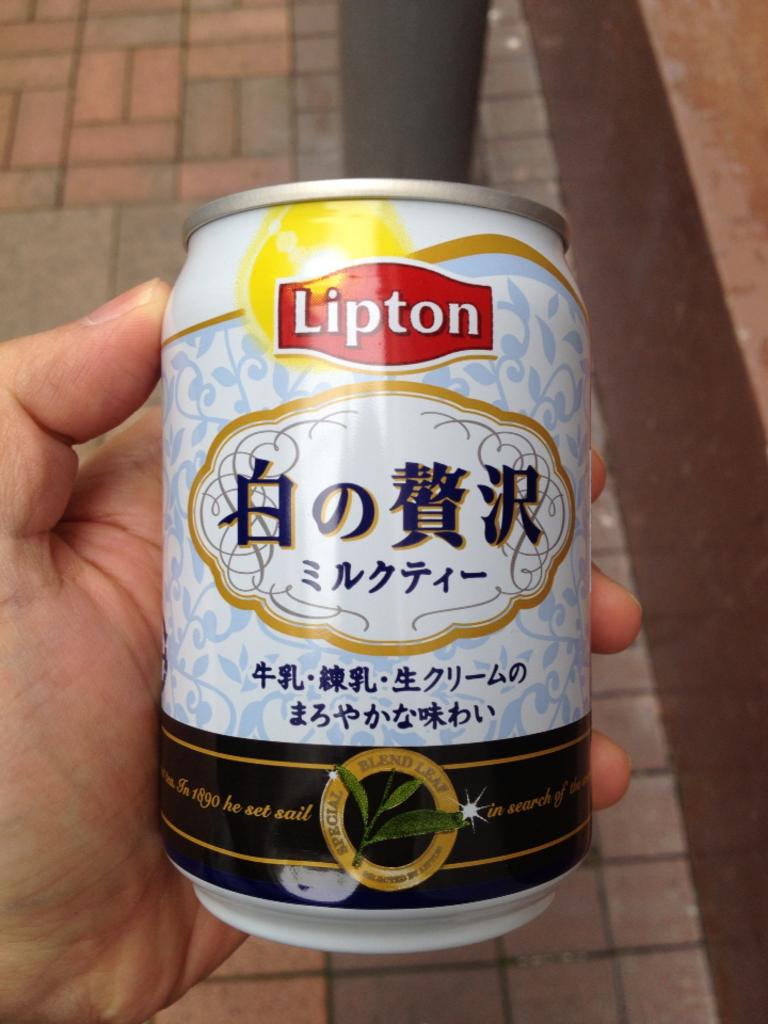Provide a one-sentence caption for the provided image. A beverage made by Lipton with some Chinese characters on the can.. 